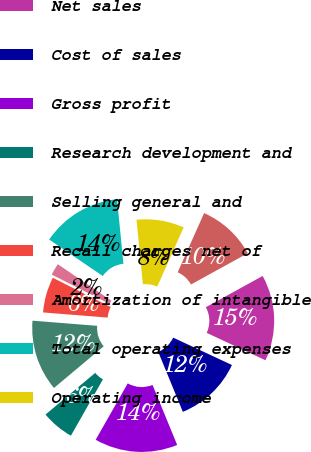<chart> <loc_0><loc_0><loc_500><loc_500><pie_chart><fcel>Statement of Earnings Data<fcel>Net sales<fcel>Cost of sales<fcel>Gross profit<fcel>Research development and<fcel>Selling general and<fcel>Recall charges net of<fcel>Amortization of intangible<fcel>Total operating expenses<fcel>Operating income<nl><fcel>10.31%<fcel>14.95%<fcel>11.86%<fcel>14.43%<fcel>5.67%<fcel>12.37%<fcel>6.19%<fcel>2.06%<fcel>13.92%<fcel>8.25%<nl></chart> 